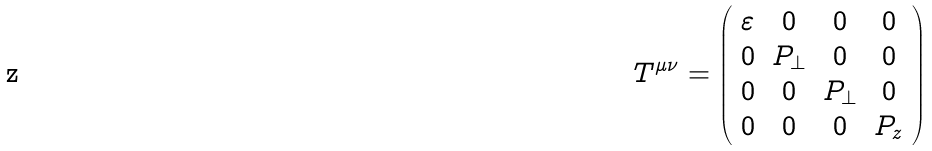<formula> <loc_0><loc_0><loc_500><loc_500>T ^ { \mu \nu } = \left ( \begin{array} { c c c c } \varepsilon & 0 & 0 & 0 \\ 0 & P _ { \perp } & 0 & 0 \\ 0 & 0 & P _ { \perp } & 0 \\ 0 & 0 & 0 & P _ { z } \end{array} \right )</formula> 